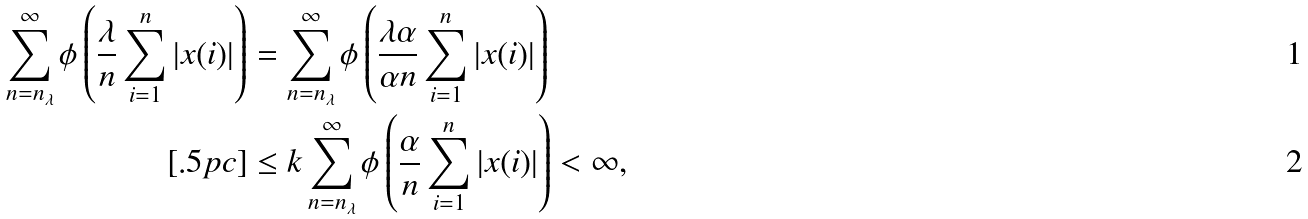Convert formula to latex. <formula><loc_0><loc_0><loc_500><loc_500>\sum _ { n = n _ { \lambda } } ^ { \infty } \phi \left ( \frac { \lambda } n \sum _ { i = 1 } ^ { n } | x ( i ) | \right ) & = \sum _ { n = n _ { \lambda } } ^ { \infty } \phi \left ( \frac { \lambda \alpha } { \alpha n } \sum _ { i = 1 } ^ { n } | x ( i ) | \right ) \\ [ . 5 p c ] & \leq k \sum _ { n = n _ { \lambda } } ^ { \infty } \phi \left ( \frac { \alpha } n \sum _ { i = 1 } ^ { n } | x ( i ) | \right ) < \infty ,</formula> 